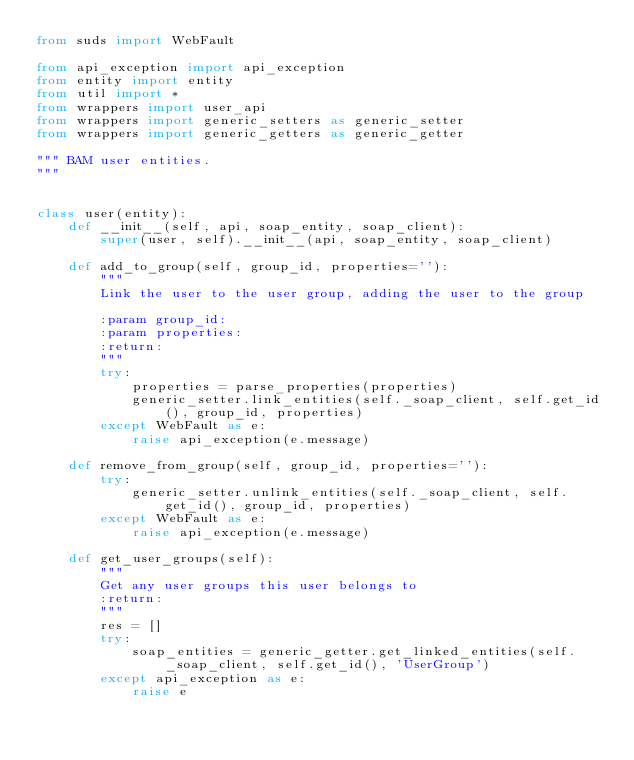Convert code to text. <code><loc_0><loc_0><loc_500><loc_500><_Python_>from suds import WebFault

from api_exception import api_exception
from entity import entity
from util import *
from wrappers import user_api
from wrappers import generic_setters as generic_setter
from wrappers import generic_getters as generic_getter

""" BAM user entities.
"""


class user(entity):
    def __init__(self, api, soap_entity, soap_client):
        super(user, self).__init__(api, soap_entity, soap_client)

    def add_to_group(self, group_id, properties=''):
        """
        Link the user to the user group, adding the user to the group

        :param group_id:
        :param properties:
        :return:
        """
        try:
            properties = parse_properties(properties)
            generic_setter.link_entities(self._soap_client, self.get_id(), group_id, properties)
        except WebFault as e:
            raise api_exception(e.message)

    def remove_from_group(self, group_id, properties=''):
        try:
            generic_setter.unlink_entities(self._soap_client, self.get_id(), group_id, properties)
        except WebFault as e:
            raise api_exception(e.message)

    def get_user_groups(self):
        """
        Get any user groups this user belongs to
        :return:
        """
        res = []
        try:
            soap_entities = generic_getter.get_linked_entities(self._soap_client, self.get_id(), 'UserGroup')
        except api_exception as e:
            raise e</code> 